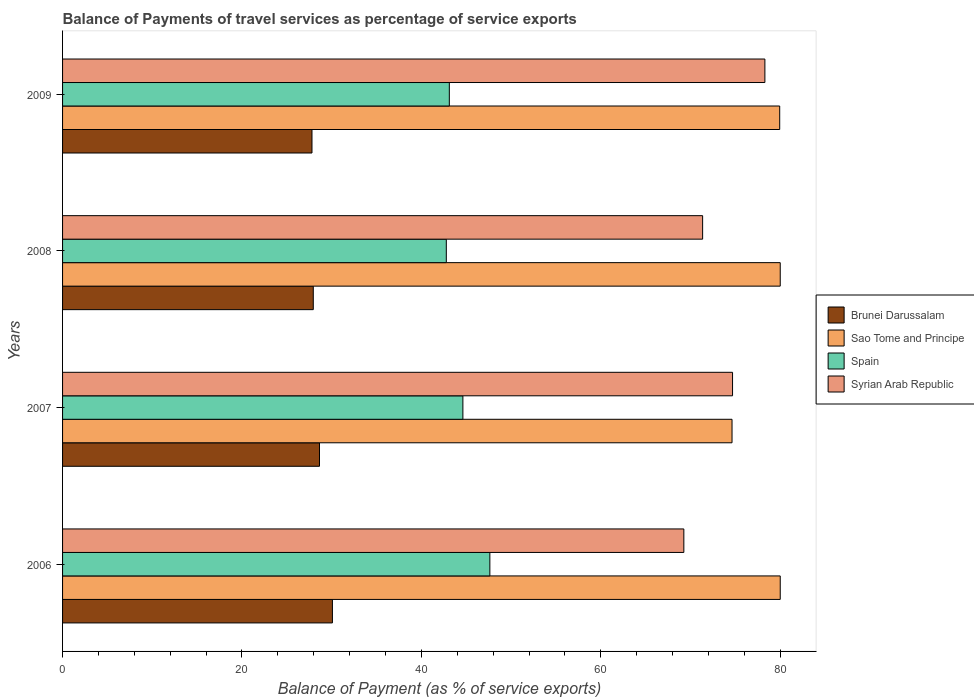How many different coloured bars are there?
Your answer should be compact. 4. How many groups of bars are there?
Offer a very short reply. 4. How many bars are there on the 1st tick from the bottom?
Keep it short and to the point. 4. In how many cases, is the number of bars for a given year not equal to the number of legend labels?
Ensure brevity in your answer.  0. What is the balance of payments of travel services in Spain in 2008?
Ensure brevity in your answer.  42.78. Across all years, what is the maximum balance of payments of travel services in Spain?
Your answer should be very brief. 47.63. Across all years, what is the minimum balance of payments of travel services in Brunei Darussalam?
Provide a short and direct response. 27.8. In which year was the balance of payments of travel services in Spain maximum?
Offer a terse response. 2006. In which year was the balance of payments of travel services in Sao Tome and Principe minimum?
Make the answer very short. 2007. What is the total balance of payments of travel services in Syrian Arab Republic in the graph?
Provide a short and direct response. 293.57. What is the difference between the balance of payments of travel services in Spain in 2007 and that in 2008?
Your response must be concise. 1.85. What is the difference between the balance of payments of travel services in Spain in 2009 and the balance of payments of travel services in Sao Tome and Principe in 2007?
Offer a very short reply. -31.51. What is the average balance of payments of travel services in Sao Tome and Principe per year?
Keep it short and to the point. 78.64. In the year 2007, what is the difference between the balance of payments of travel services in Spain and balance of payments of travel services in Sao Tome and Principe?
Offer a very short reply. -30. In how many years, is the balance of payments of travel services in Brunei Darussalam greater than 52 %?
Make the answer very short. 0. What is the ratio of the balance of payments of travel services in Sao Tome and Principe in 2007 to that in 2008?
Offer a very short reply. 0.93. What is the difference between the highest and the second highest balance of payments of travel services in Syrian Arab Republic?
Give a very brief answer. 3.6. What is the difference between the highest and the lowest balance of payments of travel services in Syrian Arab Republic?
Provide a succinct answer. 9.03. In how many years, is the balance of payments of travel services in Brunei Darussalam greater than the average balance of payments of travel services in Brunei Darussalam taken over all years?
Provide a short and direct response. 2. Is it the case that in every year, the sum of the balance of payments of travel services in Sao Tome and Principe and balance of payments of travel services in Brunei Darussalam is greater than the sum of balance of payments of travel services in Syrian Arab Republic and balance of payments of travel services in Spain?
Make the answer very short. No. What does the 4th bar from the top in 2007 represents?
Your answer should be compact. Brunei Darussalam. What does the 1st bar from the bottom in 2009 represents?
Your answer should be compact. Brunei Darussalam. Is it the case that in every year, the sum of the balance of payments of travel services in Brunei Darussalam and balance of payments of travel services in Sao Tome and Principe is greater than the balance of payments of travel services in Syrian Arab Republic?
Provide a short and direct response. Yes. Are all the bars in the graph horizontal?
Ensure brevity in your answer.  Yes. What is the difference between two consecutive major ticks on the X-axis?
Your answer should be compact. 20. Are the values on the major ticks of X-axis written in scientific E-notation?
Your answer should be very brief. No. Does the graph contain any zero values?
Your response must be concise. No. Does the graph contain grids?
Offer a terse response. No. What is the title of the graph?
Give a very brief answer. Balance of Payments of travel services as percentage of service exports. Does "High income" appear as one of the legend labels in the graph?
Your response must be concise. No. What is the label or title of the X-axis?
Offer a terse response. Balance of Payment (as % of service exports). What is the label or title of the Y-axis?
Offer a very short reply. Years. What is the Balance of Payment (as % of service exports) in Brunei Darussalam in 2006?
Offer a terse response. 30.08. What is the Balance of Payment (as % of service exports) of Sao Tome and Principe in 2006?
Provide a short and direct response. 80. What is the Balance of Payment (as % of service exports) in Spain in 2006?
Offer a very short reply. 47.63. What is the Balance of Payment (as % of service exports) in Syrian Arab Republic in 2006?
Ensure brevity in your answer.  69.25. What is the Balance of Payment (as % of service exports) of Brunei Darussalam in 2007?
Your response must be concise. 28.64. What is the Balance of Payment (as % of service exports) in Sao Tome and Principe in 2007?
Provide a succinct answer. 74.62. What is the Balance of Payment (as % of service exports) in Spain in 2007?
Provide a succinct answer. 44.62. What is the Balance of Payment (as % of service exports) of Syrian Arab Republic in 2007?
Provide a succinct answer. 74.68. What is the Balance of Payment (as % of service exports) in Brunei Darussalam in 2008?
Your answer should be very brief. 27.95. What is the Balance of Payment (as % of service exports) in Sao Tome and Principe in 2008?
Give a very brief answer. 80. What is the Balance of Payment (as % of service exports) of Spain in 2008?
Keep it short and to the point. 42.78. What is the Balance of Payment (as % of service exports) of Syrian Arab Republic in 2008?
Your answer should be compact. 71.35. What is the Balance of Payment (as % of service exports) of Brunei Darussalam in 2009?
Provide a succinct answer. 27.8. What is the Balance of Payment (as % of service exports) in Sao Tome and Principe in 2009?
Offer a very short reply. 79.94. What is the Balance of Payment (as % of service exports) in Spain in 2009?
Provide a succinct answer. 43.11. What is the Balance of Payment (as % of service exports) in Syrian Arab Republic in 2009?
Your answer should be compact. 78.29. Across all years, what is the maximum Balance of Payment (as % of service exports) in Brunei Darussalam?
Provide a short and direct response. 30.08. Across all years, what is the maximum Balance of Payment (as % of service exports) of Sao Tome and Principe?
Your answer should be very brief. 80. Across all years, what is the maximum Balance of Payment (as % of service exports) of Spain?
Provide a short and direct response. 47.63. Across all years, what is the maximum Balance of Payment (as % of service exports) of Syrian Arab Republic?
Offer a terse response. 78.29. Across all years, what is the minimum Balance of Payment (as % of service exports) of Brunei Darussalam?
Give a very brief answer. 27.8. Across all years, what is the minimum Balance of Payment (as % of service exports) of Sao Tome and Principe?
Ensure brevity in your answer.  74.62. Across all years, what is the minimum Balance of Payment (as % of service exports) of Spain?
Give a very brief answer. 42.78. Across all years, what is the minimum Balance of Payment (as % of service exports) of Syrian Arab Republic?
Give a very brief answer. 69.25. What is the total Balance of Payment (as % of service exports) in Brunei Darussalam in the graph?
Keep it short and to the point. 114.47. What is the total Balance of Payment (as % of service exports) of Sao Tome and Principe in the graph?
Provide a short and direct response. 314.56. What is the total Balance of Payment (as % of service exports) in Spain in the graph?
Offer a very short reply. 178.14. What is the total Balance of Payment (as % of service exports) in Syrian Arab Republic in the graph?
Offer a terse response. 293.57. What is the difference between the Balance of Payment (as % of service exports) of Brunei Darussalam in 2006 and that in 2007?
Your answer should be very brief. 1.44. What is the difference between the Balance of Payment (as % of service exports) in Sao Tome and Principe in 2006 and that in 2007?
Make the answer very short. 5.37. What is the difference between the Balance of Payment (as % of service exports) of Spain in 2006 and that in 2007?
Offer a terse response. 3.01. What is the difference between the Balance of Payment (as % of service exports) of Syrian Arab Republic in 2006 and that in 2007?
Your answer should be very brief. -5.43. What is the difference between the Balance of Payment (as % of service exports) of Brunei Darussalam in 2006 and that in 2008?
Give a very brief answer. 2.13. What is the difference between the Balance of Payment (as % of service exports) of Sao Tome and Principe in 2006 and that in 2008?
Offer a very short reply. 0. What is the difference between the Balance of Payment (as % of service exports) of Spain in 2006 and that in 2008?
Make the answer very short. 4.86. What is the difference between the Balance of Payment (as % of service exports) of Syrian Arab Republic in 2006 and that in 2008?
Offer a terse response. -2.09. What is the difference between the Balance of Payment (as % of service exports) of Brunei Darussalam in 2006 and that in 2009?
Offer a terse response. 2.28. What is the difference between the Balance of Payment (as % of service exports) of Sao Tome and Principe in 2006 and that in 2009?
Your response must be concise. 0.06. What is the difference between the Balance of Payment (as % of service exports) in Spain in 2006 and that in 2009?
Your answer should be very brief. 4.52. What is the difference between the Balance of Payment (as % of service exports) of Syrian Arab Republic in 2006 and that in 2009?
Your answer should be very brief. -9.03. What is the difference between the Balance of Payment (as % of service exports) of Brunei Darussalam in 2007 and that in 2008?
Your answer should be compact. 0.69. What is the difference between the Balance of Payment (as % of service exports) in Sao Tome and Principe in 2007 and that in 2008?
Keep it short and to the point. -5.37. What is the difference between the Balance of Payment (as % of service exports) in Spain in 2007 and that in 2008?
Keep it short and to the point. 1.85. What is the difference between the Balance of Payment (as % of service exports) in Syrian Arab Republic in 2007 and that in 2008?
Provide a short and direct response. 3.33. What is the difference between the Balance of Payment (as % of service exports) of Brunei Darussalam in 2007 and that in 2009?
Offer a terse response. 0.84. What is the difference between the Balance of Payment (as % of service exports) in Sao Tome and Principe in 2007 and that in 2009?
Your answer should be compact. -5.31. What is the difference between the Balance of Payment (as % of service exports) of Spain in 2007 and that in 2009?
Your answer should be compact. 1.51. What is the difference between the Balance of Payment (as % of service exports) in Syrian Arab Republic in 2007 and that in 2009?
Make the answer very short. -3.6. What is the difference between the Balance of Payment (as % of service exports) of Brunei Darussalam in 2008 and that in 2009?
Your answer should be very brief. 0.14. What is the difference between the Balance of Payment (as % of service exports) in Sao Tome and Principe in 2008 and that in 2009?
Give a very brief answer. 0.06. What is the difference between the Balance of Payment (as % of service exports) of Spain in 2008 and that in 2009?
Ensure brevity in your answer.  -0.34. What is the difference between the Balance of Payment (as % of service exports) of Syrian Arab Republic in 2008 and that in 2009?
Your answer should be compact. -6.94. What is the difference between the Balance of Payment (as % of service exports) in Brunei Darussalam in 2006 and the Balance of Payment (as % of service exports) in Sao Tome and Principe in 2007?
Provide a succinct answer. -44.54. What is the difference between the Balance of Payment (as % of service exports) in Brunei Darussalam in 2006 and the Balance of Payment (as % of service exports) in Spain in 2007?
Ensure brevity in your answer.  -14.54. What is the difference between the Balance of Payment (as % of service exports) in Brunei Darussalam in 2006 and the Balance of Payment (as % of service exports) in Syrian Arab Republic in 2007?
Your answer should be very brief. -44.6. What is the difference between the Balance of Payment (as % of service exports) of Sao Tome and Principe in 2006 and the Balance of Payment (as % of service exports) of Spain in 2007?
Offer a terse response. 35.38. What is the difference between the Balance of Payment (as % of service exports) of Sao Tome and Principe in 2006 and the Balance of Payment (as % of service exports) of Syrian Arab Republic in 2007?
Provide a succinct answer. 5.32. What is the difference between the Balance of Payment (as % of service exports) of Spain in 2006 and the Balance of Payment (as % of service exports) of Syrian Arab Republic in 2007?
Provide a succinct answer. -27.05. What is the difference between the Balance of Payment (as % of service exports) in Brunei Darussalam in 2006 and the Balance of Payment (as % of service exports) in Sao Tome and Principe in 2008?
Ensure brevity in your answer.  -49.92. What is the difference between the Balance of Payment (as % of service exports) in Brunei Darussalam in 2006 and the Balance of Payment (as % of service exports) in Spain in 2008?
Offer a very short reply. -12.7. What is the difference between the Balance of Payment (as % of service exports) in Brunei Darussalam in 2006 and the Balance of Payment (as % of service exports) in Syrian Arab Republic in 2008?
Offer a very short reply. -41.27. What is the difference between the Balance of Payment (as % of service exports) of Sao Tome and Principe in 2006 and the Balance of Payment (as % of service exports) of Spain in 2008?
Offer a very short reply. 37.22. What is the difference between the Balance of Payment (as % of service exports) in Sao Tome and Principe in 2006 and the Balance of Payment (as % of service exports) in Syrian Arab Republic in 2008?
Offer a very short reply. 8.65. What is the difference between the Balance of Payment (as % of service exports) in Spain in 2006 and the Balance of Payment (as % of service exports) in Syrian Arab Republic in 2008?
Make the answer very short. -23.72. What is the difference between the Balance of Payment (as % of service exports) of Brunei Darussalam in 2006 and the Balance of Payment (as % of service exports) of Sao Tome and Principe in 2009?
Offer a terse response. -49.86. What is the difference between the Balance of Payment (as % of service exports) in Brunei Darussalam in 2006 and the Balance of Payment (as % of service exports) in Spain in 2009?
Give a very brief answer. -13.03. What is the difference between the Balance of Payment (as % of service exports) of Brunei Darussalam in 2006 and the Balance of Payment (as % of service exports) of Syrian Arab Republic in 2009?
Your response must be concise. -48.21. What is the difference between the Balance of Payment (as % of service exports) in Sao Tome and Principe in 2006 and the Balance of Payment (as % of service exports) in Spain in 2009?
Provide a short and direct response. 36.89. What is the difference between the Balance of Payment (as % of service exports) of Sao Tome and Principe in 2006 and the Balance of Payment (as % of service exports) of Syrian Arab Republic in 2009?
Offer a terse response. 1.71. What is the difference between the Balance of Payment (as % of service exports) in Spain in 2006 and the Balance of Payment (as % of service exports) in Syrian Arab Republic in 2009?
Offer a very short reply. -30.66. What is the difference between the Balance of Payment (as % of service exports) in Brunei Darussalam in 2007 and the Balance of Payment (as % of service exports) in Sao Tome and Principe in 2008?
Ensure brevity in your answer.  -51.36. What is the difference between the Balance of Payment (as % of service exports) in Brunei Darussalam in 2007 and the Balance of Payment (as % of service exports) in Spain in 2008?
Ensure brevity in your answer.  -14.14. What is the difference between the Balance of Payment (as % of service exports) of Brunei Darussalam in 2007 and the Balance of Payment (as % of service exports) of Syrian Arab Republic in 2008?
Provide a short and direct response. -42.71. What is the difference between the Balance of Payment (as % of service exports) in Sao Tome and Principe in 2007 and the Balance of Payment (as % of service exports) in Spain in 2008?
Your response must be concise. 31.85. What is the difference between the Balance of Payment (as % of service exports) in Sao Tome and Principe in 2007 and the Balance of Payment (as % of service exports) in Syrian Arab Republic in 2008?
Ensure brevity in your answer.  3.28. What is the difference between the Balance of Payment (as % of service exports) of Spain in 2007 and the Balance of Payment (as % of service exports) of Syrian Arab Republic in 2008?
Keep it short and to the point. -26.72. What is the difference between the Balance of Payment (as % of service exports) in Brunei Darussalam in 2007 and the Balance of Payment (as % of service exports) in Sao Tome and Principe in 2009?
Provide a short and direct response. -51.3. What is the difference between the Balance of Payment (as % of service exports) in Brunei Darussalam in 2007 and the Balance of Payment (as % of service exports) in Spain in 2009?
Give a very brief answer. -14.47. What is the difference between the Balance of Payment (as % of service exports) of Brunei Darussalam in 2007 and the Balance of Payment (as % of service exports) of Syrian Arab Republic in 2009?
Your response must be concise. -49.65. What is the difference between the Balance of Payment (as % of service exports) of Sao Tome and Principe in 2007 and the Balance of Payment (as % of service exports) of Spain in 2009?
Give a very brief answer. 31.51. What is the difference between the Balance of Payment (as % of service exports) of Sao Tome and Principe in 2007 and the Balance of Payment (as % of service exports) of Syrian Arab Republic in 2009?
Your answer should be compact. -3.66. What is the difference between the Balance of Payment (as % of service exports) in Spain in 2007 and the Balance of Payment (as % of service exports) in Syrian Arab Republic in 2009?
Make the answer very short. -33.66. What is the difference between the Balance of Payment (as % of service exports) in Brunei Darussalam in 2008 and the Balance of Payment (as % of service exports) in Sao Tome and Principe in 2009?
Offer a very short reply. -51.99. What is the difference between the Balance of Payment (as % of service exports) in Brunei Darussalam in 2008 and the Balance of Payment (as % of service exports) in Spain in 2009?
Your response must be concise. -15.17. What is the difference between the Balance of Payment (as % of service exports) of Brunei Darussalam in 2008 and the Balance of Payment (as % of service exports) of Syrian Arab Republic in 2009?
Provide a short and direct response. -50.34. What is the difference between the Balance of Payment (as % of service exports) of Sao Tome and Principe in 2008 and the Balance of Payment (as % of service exports) of Spain in 2009?
Ensure brevity in your answer.  36.89. What is the difference between the Balance of Payment (as % of service exports) in Sao Tome and Principe in 2008 and the Balance of Payment (as % of service exports) in Syrian Arab Republic in 2009?
Your response must be concise. 1.71. What is the difference between the Balance of Payment (as % of service exports) of Spain in 2008 and the Balance of Payment (as % of service exports) of Syrian Arab Republic in 2009?
Offer a very short reply. -35.51. What is the average Balance of Payment (as % of service exports) of Brunei Darussalam per year?
Your response must be concise. 28.62. What is the average Balance of Payment (as % of service exports) of Sao Tome and Principe per year?
Offer a terse response. 78.64. What is the average Balance of Payment (as % of service exports) of Spain per year?
Your response must be concise. 44.54. What is the average Balance of Payment (as % of service exports) of Syrian Arab Republic per year?
Offer a terse response. 73.39. In the year 2006, what is the difference between the Balance of Payment (as % of service exports) in Brunei Darussalam and Balance of Payment (as % of service exports) in Sao Tome and Principe?
Your answer should be very brief. -49.92. In the year 2006, what is the difference between the Balance of Payment (as % of service exports) of Brunei Darussalam and Balance of Payment (as % of service exports) of Spain?
Your response must be concise. -17.55. In the year 2006, what is the difference between the Balance of Payment (as % of service exports) of Brunei Darussalam and Balance of Payment (as % of service exports) of Syrian Arab Republic?
Your response must be concise. -39.17. In the year 2006, what is the difference between the Balance of Payment (as % of service exports) in Sao Tome and Principe and Balance of Payment (as % of service exports) in Spain?
Your response must be concise. 32.37. In the year 2006, what is the difference between the Balance of Payment (as % of service exports) of Sao Tome and Principe and Balance of Payment (as % of service exports) of Syrian Arab Republic?
Make the answer very short. 10.74. In the year 2006, what is the difference between the Balance of Payment (as % of service exports) of Spain and Balance of Payment (as % of service exports) of Syrian Arab Republic?
Keep it short and to the point. -21.62. In the year 2007, what is the difference between the Balance of Payment (as % of service exports) of Brunei Darussalam and Balance of Payment (as % of service exports) of Sao Tome and Principe?
Offer a very short reply. -45.98. In the year 2007, what is the difference between the Balance of Payment (as % of service exports) of Brunei Darussalam and Balance of Payment (as % of service exports) of Spain?
Your response must be concise. -15.98. In the year 2007, what is the difference between the Balance of Payment (as % of service exports) in Brunei Darussalam and Balance of Payment (as % of service exports) in Syrian Arab Republic?
Offer a terse response. -46.04. In the year 2007, what is the difference between the Balance of Payment (as % of service exports) in Sao Tome and Principe and Balance of Payment (as % of service exports) in Spain?
Provide a short and direct response. 30. In the year 2007, what is the difference between the Balance of Payment (as % of service exports) in Sao Tome and Principe and Balance of Payment (as % of service exports) in Syrian Arab Republic?
Give a very brief answer. -0.06. In the year 2007, what is the difference between the Balance of Payment (as % of service exports) in Spain and Balance of Payment (as % of service exports) in Syrian Arab Republic?
Offer a very short reply. -30.06. In the year 2008, what is the difference between the Balance of Payment (as % of service exports) of Brunei Darussalam and Balance of Payment (as % of service exports) of Sao Tome and Principe?
Provide a short and direct response. -52.05. In the year 2008, what is the difference between the Balance of Payment (as % of service exports) in Brunei Darussalam and Balance of Payment (as % of service exports) in Spain?
Offer a terse response. -14.83. In the year 2008, what is the difference between the Balance of Payment (as % of service exports) of Brunei Darussalam and Balance of Payment (as % of service exports) of Syrian Arab Republic?
Your answer should be very brief. -43.4. In the year 2008, what is the difference between the Balance of Payment (as % of service exports) in Sao Tome and Principe and Balance of Payment (as % of service exports) in Spain?
Make the answer very short. 37.22. In the year 2008, what is the difference between the Balance of Payment (as % of service exports) of Sao Tome and Principe and Balance of Payment (as % of service exports) of Syrian Arab Republic?
Offer a very short reply. 8.65. In the year 2008, what is the difference between the Balance of Payment (as % of service exports) in Spain and Balance of Payment (as % of service exports) in Syrian Arab Republic?
Your response must be concise. -28.57. In the year 2009, what is the difference between the Balance of Payment (as % of service exports) in Brunei Darussalam and Balance of Payment (as % of service exports) in Sao Tome and Principe?
Offer a very short reply. -52.14. In the year 2009, what is the difference between the Balance of Payment (as % of service exports) of Brunei Darussalam and Balance of Payment (as % of service exports) of Spain?
Provide a succinct answer. -15.31. In the year 2009, what is the difference between the Balance of Payment (as % of service exports) in Brunei Darussalam and Balance of Payment (as % of service exports) in Syrian Arab Republic?
Provide a succinct answer. -50.48. In the year 2009, what is the difference between the Balance of Payment (as % of service exports) in Sao Tome and Principe and Balance of Payment (as % of service exports) in Spain?
Your answer should be very brief. 36.83. In the year 2009, what is the difference between the Balance of Payment (as % of service exports) in Sao Tome and Principe and Balance of Payment (as % of service exports) in Syrian Arab Republic?
Make the answer very short. 1.65. In the year 2009, what is the difference between the Balance of Payment (as % of service exports) in Spain and Balance of Payment (as % of service exports) in Syrian Arab Republic?
Offer a terse response. -35.17. What is the ratio of the Balance of Payment (as % of service exports) of Brunei Darussalam in 2006 to that in 2007?
Ensure brevity in your answer.  1.05. What is the ratio of the Balance of Payment (as % of service exports) in Sao Tome and Principe in 2006 to that in 2007?
Provide a short and direct response. 1.07. What is the ratio of the Balance of Payment (as % of service exports) in Spain in 2006 to that in 2007?
Offer a terse response. 1.07. What is the ratio of the Balance of Payment (as % of service exports) of Syrian Arab Republic in 2006 to that in 2007?
Give a very brief answer. 0.93. What is the ratio of the Balance of Payment (as % of service exports) in Brunei Darussalam in 2006 to that in 2008?
Keep it short and to the point. 1.08. What is the ratio of the Balance of Payment (as % of service exports) of Sao Tome and Principe in 2006 to that in 2008?
Offer a very short reply. 1. What is the ratio of the Balance of Payment (as % of service exports) in Spain in 2006 to that in 2008?
Offer a very short reply. 1.11. What is the ratio of the Balance of Payment (as % of service exports) in Syrian Arab Republic in 2006 to that in 2008?
Your answer should be compact. 0.97. What is the ratio of the Balance of Payment (as % of service exports) in Brunei Darussalam in 2006 to that in 2009?
Offer a terse response. 1.08. What is the ratio of the Balance of Payment (as % of service exports) of Sao Tome and Principe in 2006 to that in 2009?
Provide a succinct answer. 1. What is the ratio of the Balance of Payment (as % of service exports) of Spain in 2006 to that in 2009?
Offer a terse response. 1.1. What is the ratio of the Balance of Payment (as % of service exports) in Syrian Arab Republic in 2006 to that in 2009?
Offer a terse response. 0.88. What is the ratio of the Balance of Payment (as % of service exports) of Brunei Darussalam in 2007 to that in 2008?
Provide a succinct answer. 1.02. What is the ratio of the Balance of Payment (as % of service exports) of Sao Tome and Principe in 2007 to that in 2008?
Make the answer very short. 0.93. What is the ratio of the Balance of Payment (as % of service exports) of Spain in 2007 to that in 2008?
Make the answer very short. 1.04. What is the ratio of the Balance of Payment (as % of service exports) of Syrian Arab Republic in 2007 to that in 2008?
Make the answer very short. 1.05. What is the ratio of the Balance of Payment (as % of service exports) in Brunei Darussalam in 2007 to that in 2009?
Offer a terse response. 1.03. What is the ratio of the Balance of Payment (as % of service exports) of Sao Tome and Principe in 2007 to that in 2009?
Provide a succinct answer. 0.93. What is the ratio of the Balance of Payment (as % of service exports) in Spain in 2007 to that in 2009?
Ensure brevity in your answer.  1.03. What is the ratio of the Balance of Payment (as % of service exports) in Syrian Arab Republic in 2007 to that in 2009?
Offer a very short reply. 0.95. What is the ratio of the Balance of Payment (as % of service exports) in Syrian Arab Republic in 2008 to that in 2009?
Your response must be concise. 0.91. What is the difference between the highest and the second highest Balance of Payment (as % of service exports) of Brunei Darussalam?
Make the answer very short. 1.44. What is the difference between the highest and the second highest Balance of Payment (as % of service exports) of Spain?
Ensure brevity in your answer.  3.01. What is the difference between the highest and the second highest Balance of Payment (as % of service exports) of Syrian Arab Republic?
Keep it short and to the point. 3.6. What is the difference between the highest and the lowest Balance of Payment (as % of service exports) in Brunei Darussalam?
Offer a terse response. 2.28. What is the difference between the highest and the lowest Balance of Payment (as % of service exports) of Sao Tome and Principe?
Keep it short and to the point. 5.37. What is the difference between the highest and the lowest Balance of Payment (as % of service exports) of Spain?
Your response must be concise. 4.86. What is the difference between the highest and the lowest Balance of Payment (as % of service exports) of Syrian Arab Republic?
Keep it short and to the point. 9.03. 